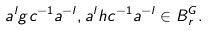Convert formula to latex. <formula><loc_0><loc_0><loc_500><loc_500>a ^ { l } g c ^ { - 1 } a ^ { - l } , a ^ { l } h c ^ { - 1 } a ^ { - l } \in B ^ { G } _ { r } .</formula> 